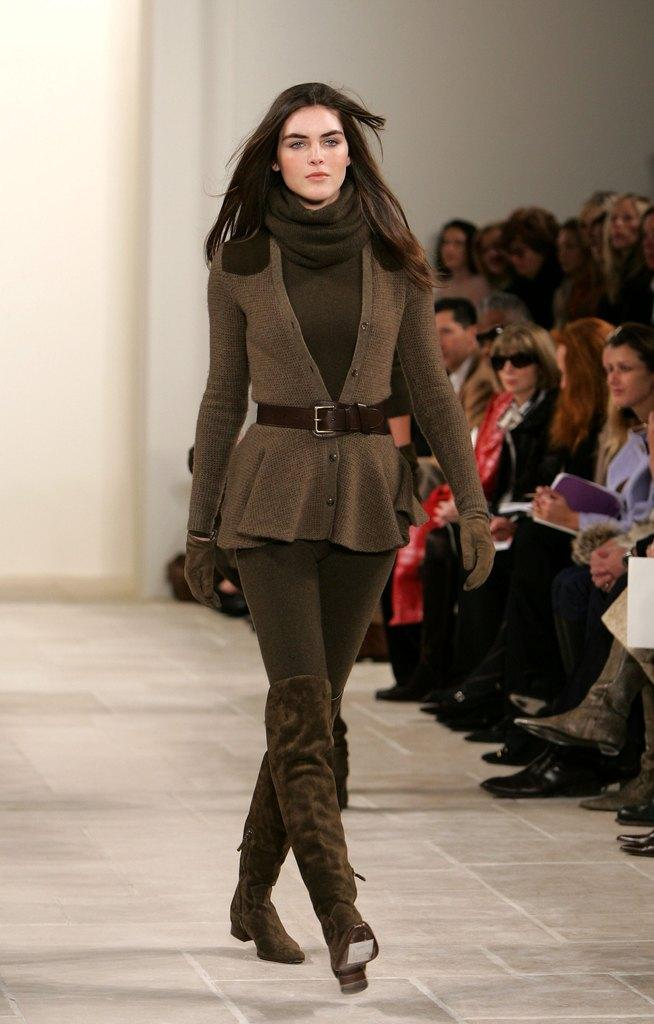Who is the main subject in the image? There is a lady in the image. What is the lady doing in the image? The lady is walking. Are there any other people in the image besides the lady? Yes, there are people in the image. What type of bun is the lady holding in the image? There is no bun present in the image; the lady is simply walking. 